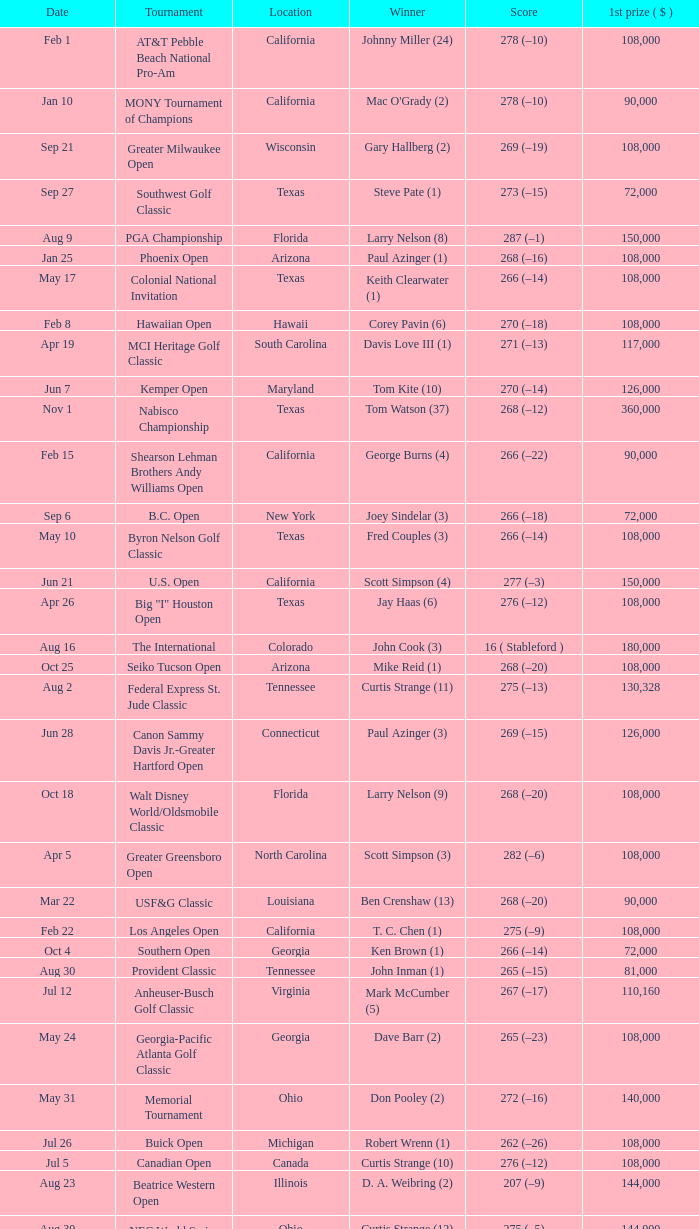What is the date where the winner was Tom Kite (10)? Jun 7. 